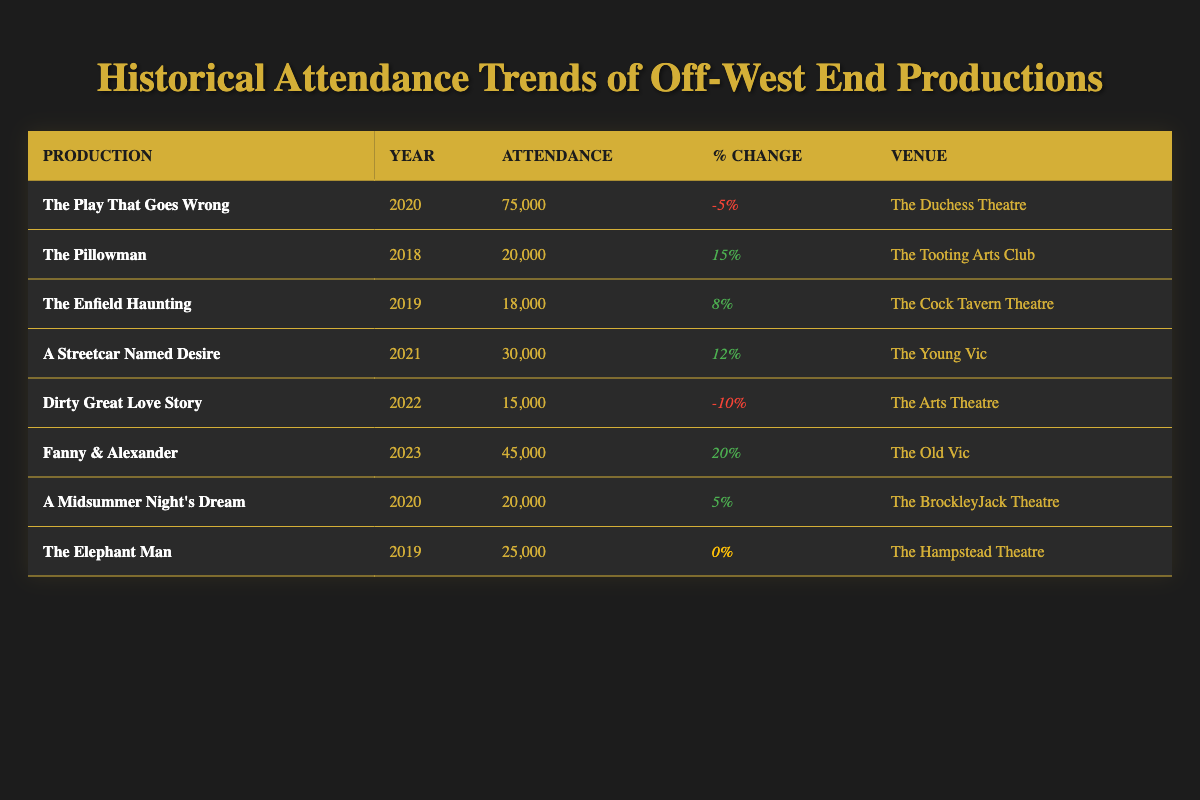What was the attendance for "A Streetcar Named Desire"? According to the table, the attendance for "A Streetcar Named Desire" in 2021 was 30,000.
Answer: 30,000 Which production had the highest attendance? The table shows that "The Play That Goes Wrong" in 2020 had the highest attendance at 75,000.
Answer: 75,000 How many productions had a positive percent change in attendance? The table lists four productions with positive percent changes: "The Pillowman" (15%), "The Enfield Haunting" (8%), "A Streetcar Named Desire" (12%), and "Fanny & Alexander" (20%). Therefore, there are four productions with a positive percent change.
Answer: 4 What was the average attendance for productions in 2019? There are three productions from 2019: "The Enfield Haunting" (18,000), "The Elephant Man" (25,000), and the average is calculated as (18,000 + 25,000) / 2 = 21,500.
Answer: 21,500 Did "Dirty Great Love Story" have a higher attendance than "The Elephant Man"? "Dirty Great Love Story" had an attendance of 15,000, while "The Elephant Man" had 25,000. Since 15,000 is less than 25,000, the statement is false.
Answer: No Which production saw the greatest increase in attendance percentage? The production with the greatest increase was "Fanny & Alexander" in 2023, with a percent change of 20%.
Answer: 20% What is the total attendance of all productions at The Arts Theatre? Only one production, "Dirty Great Love Story," was held at The Arts Theatre with an attendance of 15,000. Thus, the total attendance at The Arts Theatre is simply 15,000.
Answer: 15,000 Was there any production with no change in attendance compared to the previous year? Yes, "The Elephant Man" had a percent change of 0%, indicating no change in attendance.
Answer: Yes 